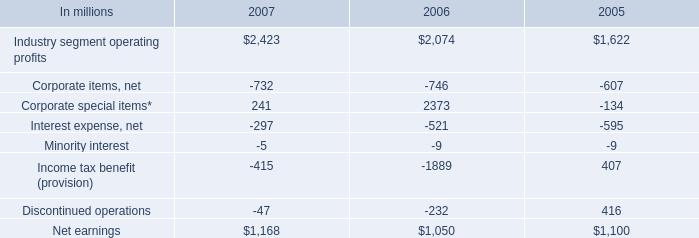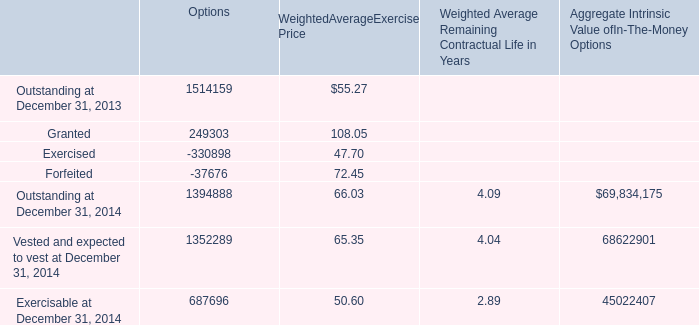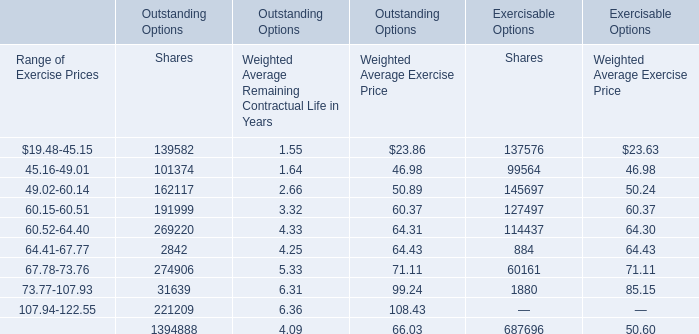What was the sum of Weighted AverageExercise Price without those Weighted AverageExercise Price greater than 60, in 2013? 
Computations: (47.70 + 55.27)
Answer: 102.97. 